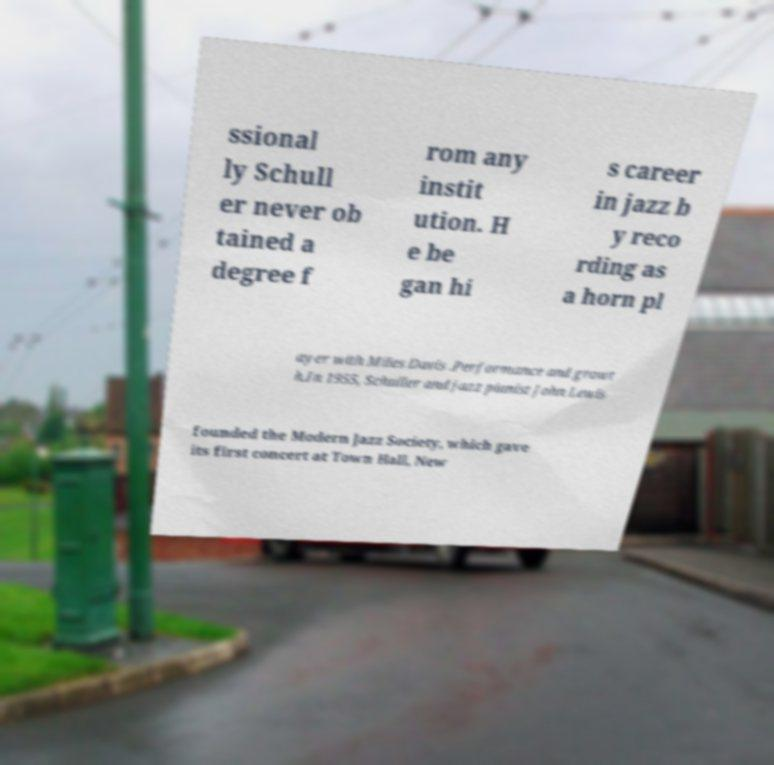Can you read and provide the text displayed in the image?This photo seems to have some interesting text. Can you extract and type it out for me? ssional ly Schull er never ob tained a degree f rom any instit ution. H e be gan hi s career in jazz b y reco rding as a horn pl ayer with Miles Davis .Performance and growt h.In 1955, Schuller and jazz pianist John Lewis founded the Modern Jazz Society, which gave its first concert at Town Hall, New 